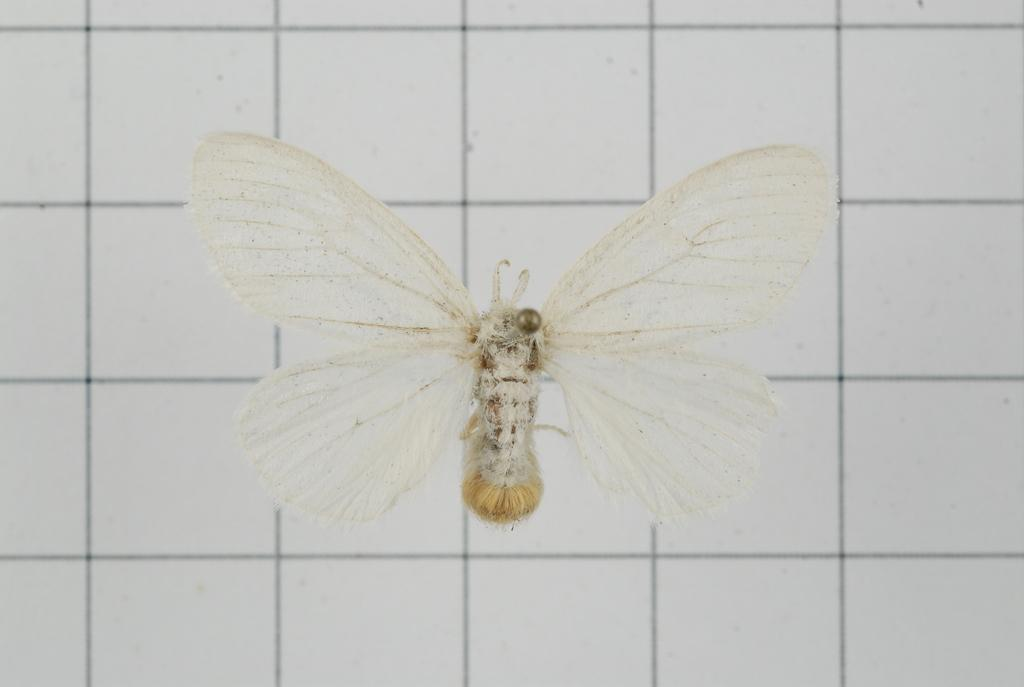What is present in the image? There is a fly in the image. Can you describe the background of the fly? The background of the fly is blurred. How many rabbits are resting on the beds in the image? There are no rabbits or beds present in the image; it only features a fly with a blurred background. 